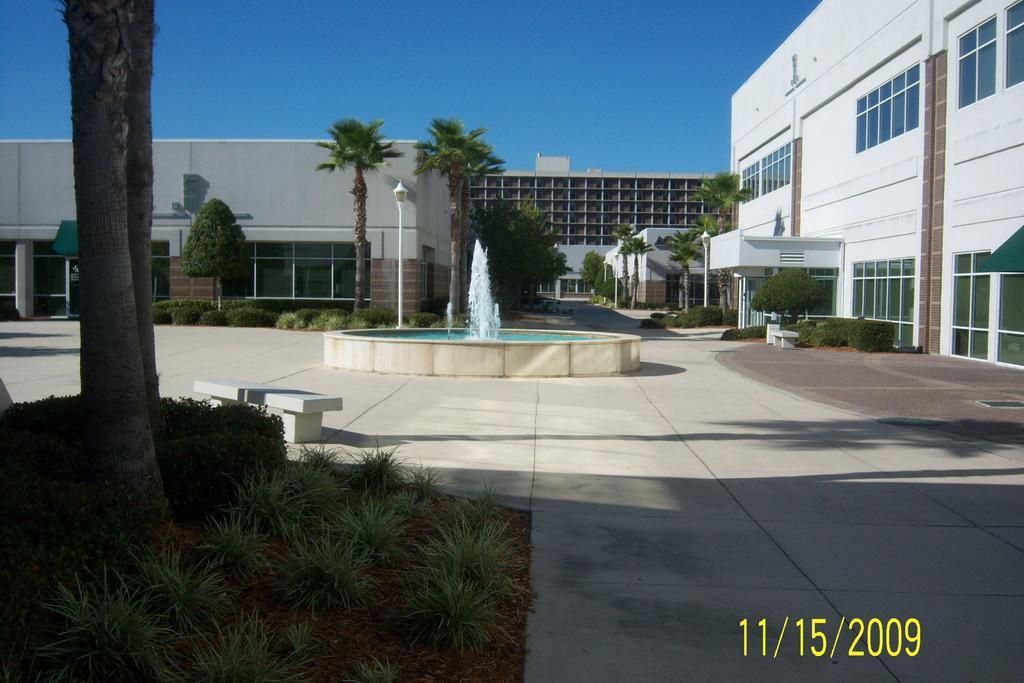Describe this image in one or two sentences. In this picture we can see a building on the right side, there is a water fountain here, there are some trees here, at the left bottom we can see some plants, there is a pole and light here, we can see the sky at the top of the picture. 